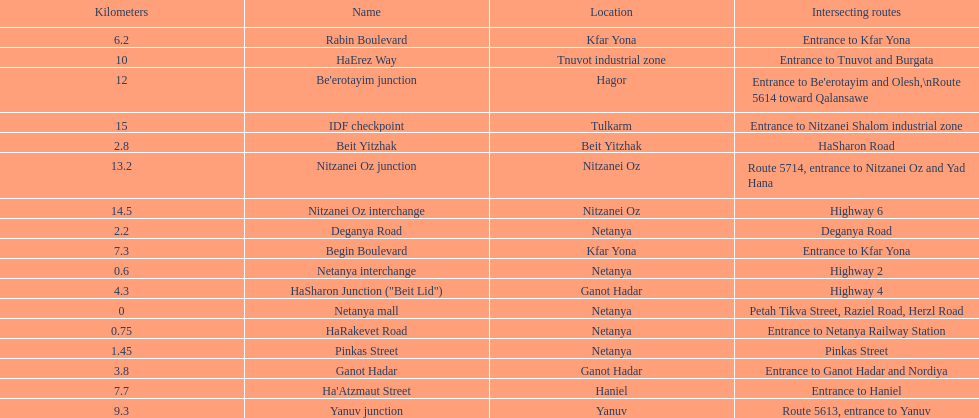Which section is longest?? IDF checkpoint. 